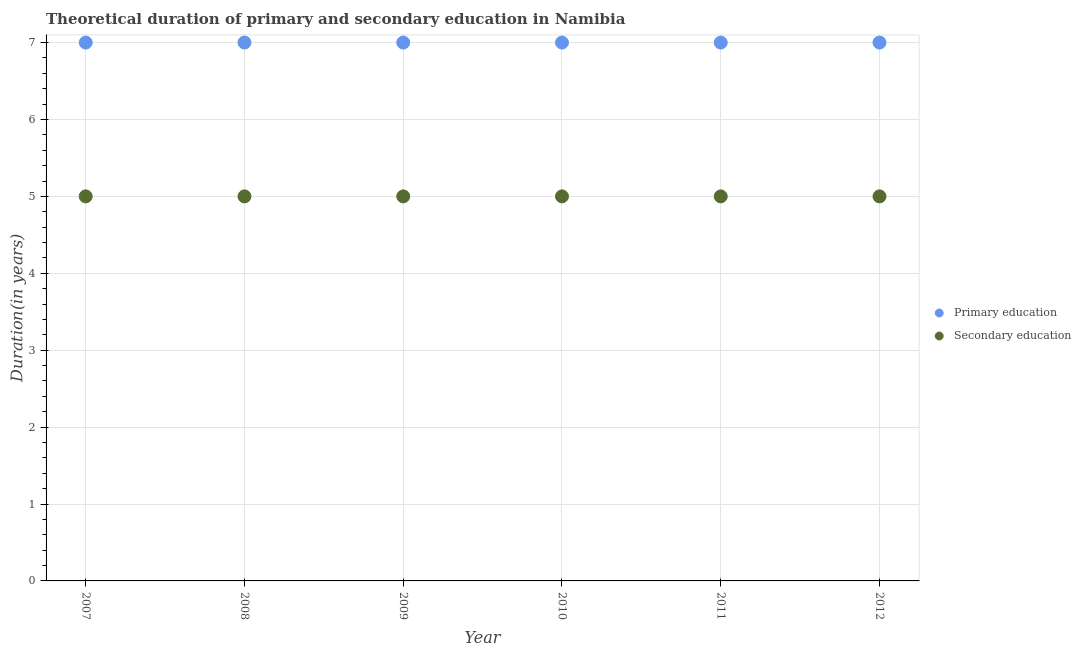Is the number of dotlines equal to the number of legend labels?
Offer a very short reply. Yes. What is the duration of primary education in 2007?
Provide a succinct answer. 7. Across all years, what is the maximum duration of secondary education?
Provide a short and direct response. 5. Across all years, what is the minimum duration of secondary education?
Offer a very short reply. 5. In which year was the duration of secondary education minimum?
Make the answer very short. 2007. What is the total duration of primary education in the graph?
Keep it short and to the point. 42. What is the difference between the duration of primary education in 2007 and that in 2012?
Give a very brief answer. 0. What is the difference between the duration of secondary education in 2010 and the duration of primary education in 2009?
Your response must be concise. -2. What is the average duration of primary education per year?
Your answer should be compact. 7. In the year 2009, what is the difference between the duration of primary education and duration of secondary education?
Ensure brevity in your answer.  2. What is the ratio of the duration of primary education in 2008 to that in 2012?
Ensure brevity in your answer.  1. Is the duration of primary education in 2007 less than that in 2010?
Provide a succinct answer. No. What is the difference between the highest and the second highest duration of secondary education?
Ensure brevity in your answer.  0. What is the difference between the highest and the lowest duration of secondary education?
Your answer should be very brief. 0. How many dotlines are there?
Make the answer very short. 2. What is the difference between two consecutive major ticks on the Y-axis?
Give a very brief answer. 1. Are the values on the major ticks of Y-axis written in scientific E-notation?
Offer a very short reply. No. Does the graph contain grids?
Ensure brevity in your answer.  Yes. Where does the legend appear in the graph?
Offer a very short reply. Center right. How are the legend labels stacked?
Give a very brief answer. Vertical. What is the title of the graph?
Keep it short and to the point. Theoretical duration of primary and secondary education in Namibia. Does "Subsidies" appear as one of the legend labels in the graph?
Offer a very short reply. No. What is the label or title of the Y-axis?
Keep it short and to the point. Duration(in years). What is the Duration(in years) of Secondary education in 2008?
Offer a terse response. 5. What is the Duration(in years) in Primary education in 2009?
Provide a short and direct response. 7. What is the Duration(in years) in Secondary education in 2009?
Your answer should be very brief. 5. What is the Duration(in years) of Primary education in 2010?
Keep it short and to the point. 7. What is the Duration(in years) of Secondary education in 2010?
Give a very brief answer. 5. What is the Duration(in years) of Primary education in 2011?
Your answer should be very brief. 7. What is the Duration(in years) of Secondary education in 2011?
Provide a succinct answer. 5. What is the Duration(in years) of Primary education in 2012?
Make the answer very short. 7. Across all years, what is the maximum Duration(in years) in Primary education?
Offer a terse response. 7. Across all years, what is the maximum Duration(in years) in Secondary education?
Keep it short and to the point. 5. Across all years, what is the minimum Duration(in years) of Primary education?
Give a very brief answer. 7. Across all years, what is the minimum Duration(in years) in Secondary education?
Your answer should be very brief. 5. What is the total Duration(in years) in Primary education in the graph?
Make the answer very short. 42. What is the difference between the Duration(in years) in Primary education in 2007 and that in 2008?
Ensure brevity in your answer.  0. What is the difference between the Duration(in years) in Primary education in 2007 and that in 2009?
Your answer should be very brief. 0. What is the difference between the Duration(in years) in Primary education in 2007 and that in 2010?
Your response must be concise. 0. What is the difference between the Duration(in years) in Secondary education in 2007 and that in 2010?
Make the answer very short. 0. What is the difference between the Duration(in years) of Secondary education in 2007 and that in 2011?
Ensure brevity in your answer.  0. What is the difference between the Duration(in years) in Secondary education in 2008 and that in 2009?
Provide a succinct answer. 0. What is the difference between the Duration(in years) in Primary education in 2008 and that in 2010?
Keep it short and to the point. 0. What is the difference between the Duration(in years) of Secondary education in 2008 and that in 2010?
Make the answer very short. 0. What is the difference between the Duration(in years) in Primary education in 2008 and that in 2011?
Offer a very short reply. 0. What is the difference between the Duration(in years) in Secondary education in 2008 and that in 2012?
Your response must be concise. 0. What is the difference between the Duration(in years) of Primary education in 2009 and that in 2010?
Your answer should be very brief. 0. What is the difference between the Duration(in years) in Secondary education in 2009 and that in 2010?
Provide a succinct answer. 0. What is the difference between the Duration(in years) in Primary education in 2009 and that in 2012?
Offer a very short reply. 0. What is the difference between the Duration(in years) of Secondary education in 2009 and that in 2012?
Offer a very short reply. 0. What is the difference between the Duration(in years) of Primary education in 2010 and that in 2011?
Give a very brief answer. 0. What is the difference between the Duration(in years) in Secondary education in 2010 and that in 2011?
Ensure brevity in your answer.  0. What is the difference between the Duration(in years) in Primary education in 2010 and that in 2012?
Your response must be concise. 0. What is the difference between the Duration(in years) of Secondary education in 2010 and that in 2012?
Offer a very short reply. 0. What is the difference between the Duration(in years) of Secondary education in 2011 and that in 2012?
Keep it short and to the point. 0. What is the difference between the Duration(in years) in Primary education in 2007 and the Duration(in years) in Secondary education in 2008?
Give a very brief answer. 2. What is the difference between the Duration(in years) of Primary education in 2007 and the Duration(in years) of Secondary education in 2009?
Your answer should be compact. 2. What is the difference between the Duration(in years) of Primary education in 2007 and the Duration(in years) of Secondary education in 2010?
Your answer should be compact. 2. What is the difference between the Duration(in years) of Primary education in 2008 and the Duration(in years) of Secondary education in 2009?
Keep it short and to the point. 2. What is the difference between the Duration(in years) of Primary education in 2008 and the Duration(in years) of Secondary education in 2010?
Offer a very short reply. 2. What is the difference between the Duration(in years) in Primary education in 2008 and the Duration(in years) in Secondary education in 2012?
Provide a succinct answer. 2. What is the difference between the Duration(in years) of Primary education in 2009 and the Duration(in years) of Secondary education in 2010?
Your response must be concise. 2. What is the difference between the Duration(in years) of Primary education in 2009 and the Duration(in years) of Secondary education in 2011?
Offer a very short reply. 2. What is the difference between the Duration(in years) in Primary education in 2010 and the Duration(in years) in Secondary education in 2012?
Your response must be concise. 2. What is the average Duration(in years) in Secondary education per year?
Give a very brief answer. 5. In the year 2007, what is the difference between the Duration(in years) of Primary education and Duration(in years) of Secondary education?
Offer a very short reply. 2. In the year 2008, what is the difference between the Duration(in years) in Primary education and Duration(in years) in Secondary education?
Offer a terse response. 2. In the year 2009, what is the difference between the Duration(in years) of Primary education and Duration(in years) of Secondary education?
Your answer should be compact. 2. In the year 2012, what is the difference between the Duration(in years) in Primary education and Duration(in years) in Secondary education?
Provide a short and direct response. 2. What is the ratio of the Duration(in years) of Primary education in 2007 to that in 2009?
Your answer should be very brief. 1. What is the ratio of the Duration(in years) of Secondary education in 2007 to that in 2010?
Ensure brevity in your answer.  1. What is the ratio of the Duration(in years) in Primary education in 2007 to that in 2011?
Ensure brevity in your answer.  1. What is the ratio of the Duration(in years) of Secondary education in 2007 to that in 2011?
Your response must be concise. 1. What is the ratio of the Duration(in years) in Secondary education in 2007 to that in 2012?
Ensure brevity in your answer.  1. What is the ratio of the Duration(in years) of Primary education in 2008 to that in 2009?
Offer a very short reply. 1. What is the ratio of the Duration(in years) of Secondary education in 2008 to that in 2009?
Provide a succinct answer. 1. What is the ratio of the Duration(in years) of Primary education in 2008 to that in 2010?
Give a very brief answer. 1. What is the ratio of the Duration(in years) of Primary education in 2008 to that in 2011?
Your answer should be very brief. 1. What is the ratio of the Duration(in years) in Secondary education in 2008 to that in 2011?
Provide a short and direct response. 1. What is the ratio of the Duration(in years) in Secondary education in 2008 to that in 2012?
Make the answer very short. 1. What is the ratio of the Duration(in years) of Primary education in 2009 to that in 2010?
Provide a succinct answer. 1. What is the ratio of the Duration(in years) in Primary education in 2009 to that in 2011?
Offer a very short reply. 1. What is the ratio of the Duration(in years) of Primary education in 2009 to that in 2012?
Your response must be concise. 1. What is the ratio of the Duration(in years) in Secondary education in 2009 to that in 2012?
Your answer should be compact. 1. What is the ratio of the Duration(in years) of Secondary education in 2010 to that in 2011?
Your answer should be compact. 1. What is the ratio of the Duration(in years) of Primary education in 2011 to that in 2012?
Your response must be concise. 1. What is the ratio of the Duration(in years) of Secondary education in 2011 to that in 2012?
Offer a very short reply. 1. What is the difference between the highest and the second highest Duration(in years) of Primary education?
Offer a terse response. 0. What is the difference between the highest and the lowest Duration(in years) of Primary education?
Give a very brief answer. 0. What is the difference between the highest and the lowest Duration(in years) of Secondary education?
Make the answer very short. 0. 